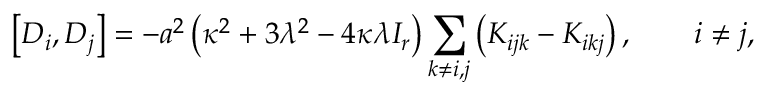<formula> <loc_0><loc_0><loc_500><loc_500>\left [ D _ { i } , D _ { j } \right ] = - a ^ { 2 } \left ( \kappa ^ { 2 } + 3 \lambda ^ { 2 } - 4 \kappa \lambda I _ { r } \right ) \sum _ { k \ne i , j } \left ( K _ { i j k } - K _ { i k j } \right ) , \quad i \ne j ,</formula> 